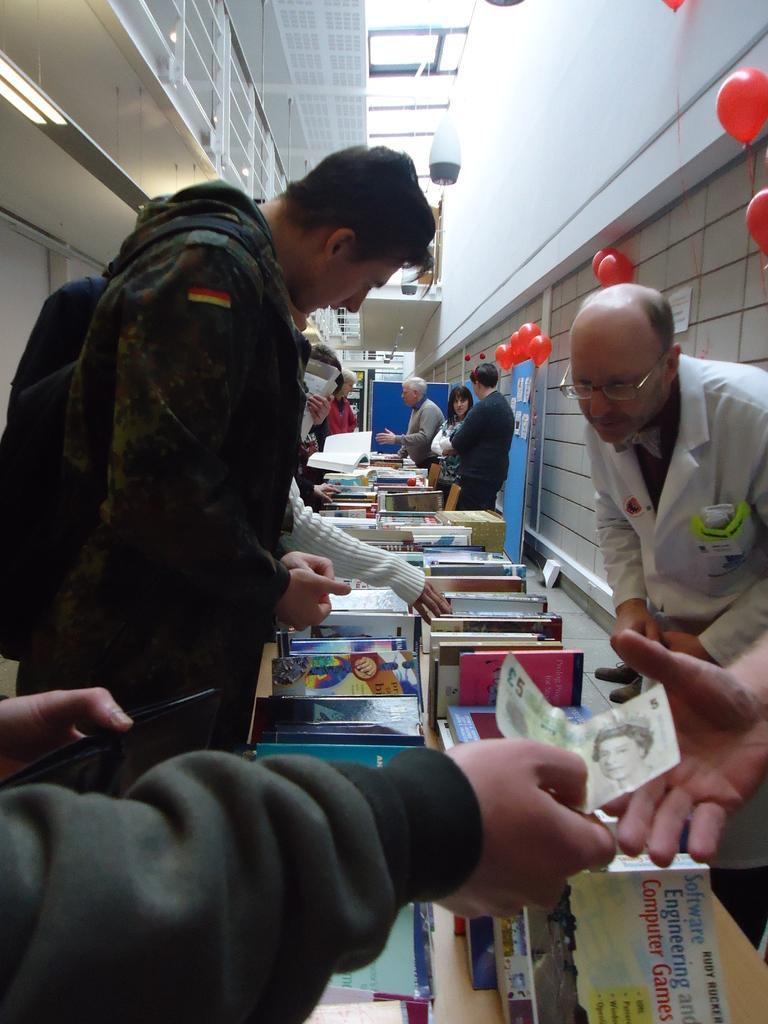In one or two sentences, can you explain what this image depicts? In this image it looks like a bookshop in which there are few people looking the books. On the right side there are few people standing on the floor. At the bottom there is a person giving money to another person. There are red colour balloons which are attached to the wall. At the top there are lights which are hanged to the roof. On the left side top there are racks. In the middle there are so many books. 